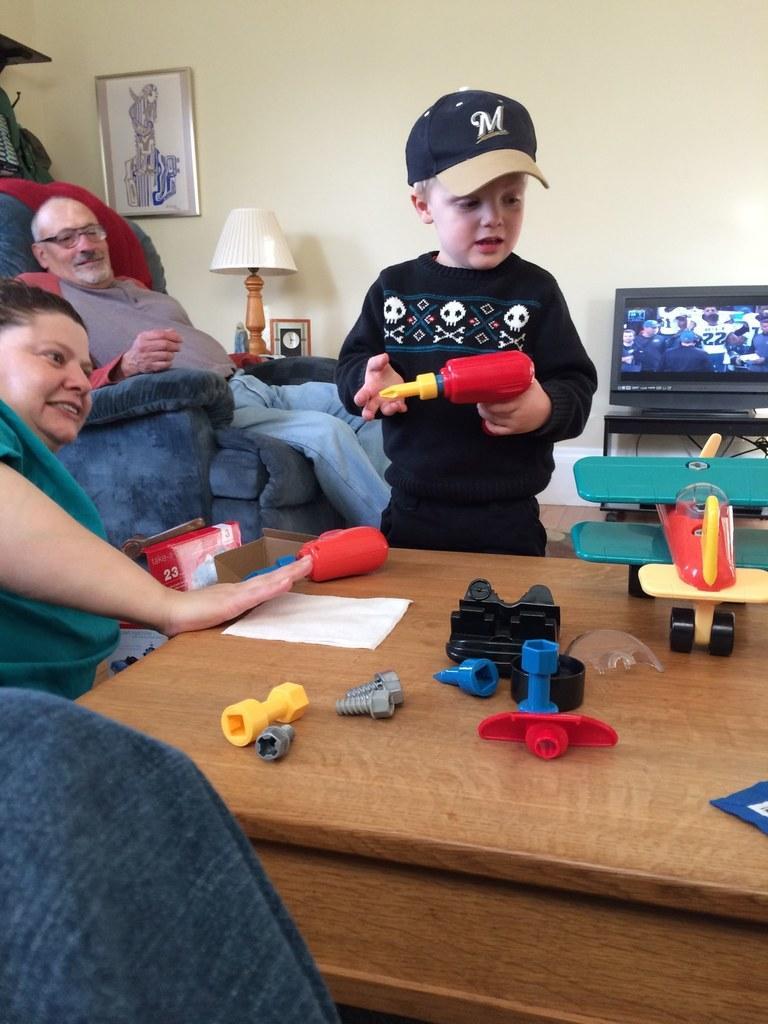In one or two sentences, can you explain what this image depicts? In this image there are three persons at the middle of the image there is a kid who is playing with toys and at the right side of the image there is a T. V. and at the top left of the image there is a painting attached to the wall. 